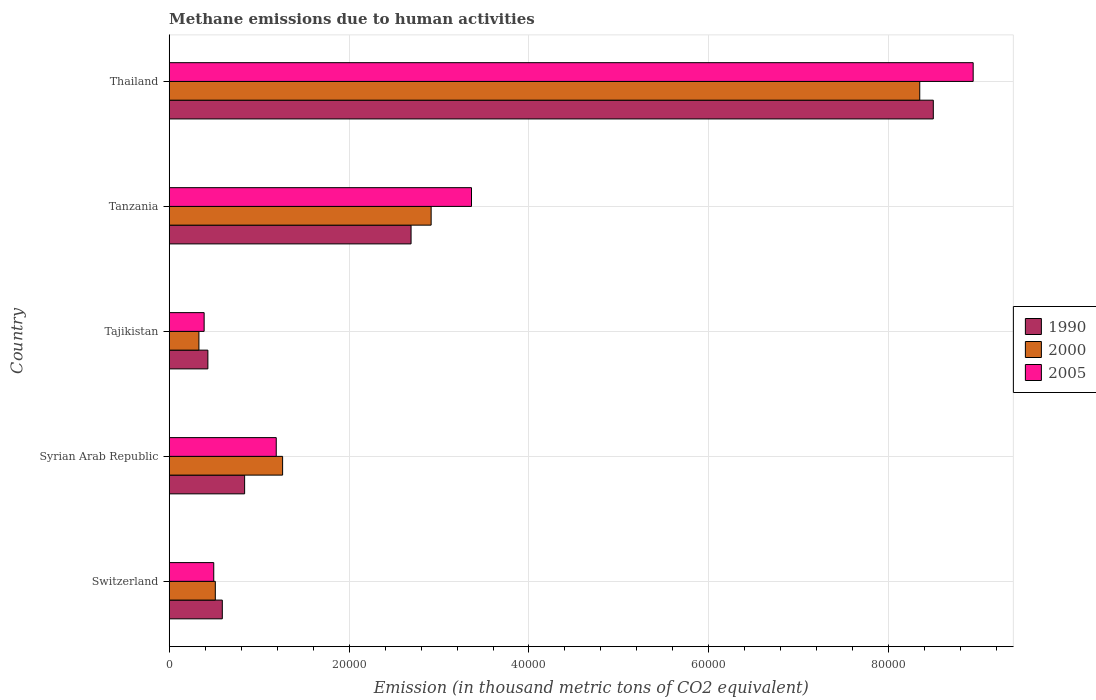How many groups of bars are there?
Your response must be concise. 5. Are the number of bars per tick equal to the number of legend labels?
Your answer should be very brief. Yes. How many bars are there on the 1st tick from the bottom?
Your answer should be compact. 3. What is the label of the 1st group of bars from the top?
Give a very brief answer. Thailand. In how many cases, is the number of bars for a given country not equal to the number of legend labels?
Give a very brief answer. 0. What is the amount of methane emitted in 1990 in Thailand?
Keep it short and to the point. 8.50e+04. Across all countries, what is the maximum amount of methane emitted in 1990?
Your response must be concise. 8.50e+04. Across all countries, what is the minimum amount of methane emitted in 2005?
Ensure brevity in your answer.  3884.9. In which country was the amount of methane emitted in 1990 maximum?
Give a very brief answer. Thailand. In which country was the amount of methane emitted in 2000 minimum?
Make the answer very short. Tajikistan. What is the total amount of methane emitted in 2000 in the graph?
Ensure brevity in your answer.  1.34e+05. What is the difference between the amount of methane emitted in 1990 in Syrian Arab Republic and that in Tajikistan?
Your answer should be compact. 4085.9. What is the difference between the amount of methane emitted in 2000 in Syrian Arab Republic and the amount of methane emitted in 1990 in Switzerland?
Your answer should be compact. 6704. What is the average amount of methane emitted in 2005 per country?
Make the answer very short. 2.87e+04. What is the difference between the amount of methane emitted in 2000 and amount of methane emitted in 2005 in Syrian Arab Republic?
Offer a terse response. 707.6. In how many countries, is the amount of methane emitted in 1990 greater than 24000 thousand metric tons?
Offer a very short reply. 2. What is the ratio of the amount of methane emitted in 2000 in Tajikistan to that in Tanzania?
Your answer should be very brief. 0.11. Is the amount of methane emitted in 2000 in Syrian Arab Republic less than that in Tanzania?
Provide a succinct answer. Yes. Is the difference between the amount of methane emitted in 2000 in Syrian Arab Republic and Tajikistan greater than the difference between the amount of methane emitted in 2005 in Syrian Arab Republic and Tajikistan?
Offer a very short reply. Yes. What is the difference between the highest and the second highest amount of methane emitted in 2000?
Ensure brevity in your answer.  5.43e+04. What is the difference between the highest and the lowest amount of methane emitted in 1990?
Make the answer very short. 8.07e+04. What does the 3rd bar from the top in Switzerland represents?
Your answer should be very brief. 1990. How many bars are there?
Offer a very short reply. 15. Are all the bars in the graph horizontal?
Ensure brevity in your answer.  Yes. How many countries are there in the graph?
Make the answer very short. 5. What is the difference between two consecutive major ticks on the X-axis?
Your response must be concise. 2.00e+04. Are the values on the major ticks of X-axis written in scientific E-notation?
Provide a succinct answer. No. Does the graph contain grids?
Offer a terse response. Yes. Where does the legend appear in the graph?
Offer a very short reply. Center right. How are the legend labels stacked?
Your answer should be very brief. Vertical. What is the title of the graph?
Keep it short and to the point. Methane emissions due to human activities. What is the label or title of the X-axis?
Provide a short and direct response. Emission (in thousand metric tons of CO2 equivalent). What is the label or title of the Y-axis?
Give a very brief answer. Country. What is the Emission (in thousand metric tons of CO2 equivalent) in 1990 in Switzerland?
Make the answer very short. 5904.8. What is the Emission (in thousand metric tons of CO2 equivalent) of 2000 in Switzerland?
Offer a very short reply. 5126.2. What is the Emission (in thousand metric tons of CO2 equivalent) of 2005 in Switzerland?
Your answer should be very brief. 4953.4. What is the Emission (in thousand metric tons of CO2 equivalent) of 1990 in Syrian Arab Republic?
Offer a terse response. 8384.9. What is the Emission (in thousand metric tons of CO2 equivalent) of 2000 in Syrian Arab Republic?
Keep it short and to the point. 1.26e+04. What is the Emission (in thousand metric tons of CO2 equivalent) of 2005 in Syrian Arab Republic?
Your answer should be compact. 1.19e+04. What is the Emission (in thousand metric tons of CO2 equivalent) of 1990 in Tajikistan?
Keep it short and to the point. 4299. What is the Emission (in thousand metric tons of CO2 equivalent) of 2000 in Tajikistan?
Offer a terse response. 3303.6. What is the Emission (in thousand metric tons of CO2 equivalent) in 2005 in Tajikistan?
Offer a very short reply. 3884.9. What is the Emission (in thousand metric tons of CO2 equivalent) in 1990 in Tanzania?
Make the answer very short. 2.69e+04. What is the Emission (in thousand metric tons of CO2 equivalent) of 2000 in Tanzania?
Ensure brevity in your answer.  2.91e+04. What is the Emission (in thousand metric tons of CO2 equivalent) of 2005 in Tanzania?
Offer a very short reply. 3.36e+04. What is the Emission (in thousand metric tons of CO2 equivalent) in 1990 in Thailand?
Your response must be concise. 8.50e+04. What is the Emission (in thousand metric tons of CO2 equivalent) of 2000 in Thailand?
Offer a very short reply. 8.34e+04. What is the Emission (in thousand metric tons of CO2 equivalent) of 2005 in Thailand?
Ensure brevity in your answer.  8.94e+04. Across all countries, what is the maximum Emission (in thousand metric tons of CO2 equivalent) in 1990?
Ensure brevity in your answer.  8.50e+04. Across all countries, what is the maximum Emission (in thousand metric tons of CO2 equivalent) of 2000?
Offer a terse response. 8.34e+04. Across all countries, what is the maximum Emission (in thousand metric tons of CO2 equivalent) of 2005?
Keep it short and to the point. 8.94e+04. Across all countries, what is the minimum Emission (in thousand metric tons of CO2 equivalent) in 1990?
Your answer should be compact. 4299. Across all countries, what is the minimum Emission (in thousand metric tons of CO2 equivalent) in 2000?
Ensure brevity in your answer.  3303.6. Across all countries, what is the minimum Emission (in thousand metric tons of CO2 equivalent) of 2005?
Your response must be concise. 3884.9. What is the total Emission (in thousand metric tons of CO2 equivalent) in 1990 in the graph?
Provide a short and direct response. 1.30e+05. What is the total Emission (in thousand metric tons of CO2 equivalent) of 2000 in the graph?
Provide a succinct answer. 1.34e+05. What is the total Emission (in thousand metric tons of CO2 equivalent) in 2005 in the graph?
Ensure brevity in your answer.  1.44e+05. What is the difference between the Emission (in thousand metric tons of CO2 equivalent) in 1990 in Switzerland and that in Syrian Arab Republic?
Ensure brevity in your answer.  -2480.1. What is the difference between the Emission (in thousand metric tons of CO2 equivalent) in 2000 in Switzerland and that in Syrian Arab Republic?
Provide a short and direct response. -7482.6. What is the difference between the Emission (in thousand metric tons of CO2 equivalent) of 2005 in Switzerland and that in Syrian Arab Republic?
Offer a terse response. -6947.8. What is the difference between the Emission (in thousand metric tons of CO2 equivalent) in 1990 in Switzerland and that in Tajikistan?
Make the answer very short. 1605.8. What is the difference between the Emission (in thousand metric tons of CO2 equivalent) in 2000 in Switzerland and that in Tajikistan?
Offer a very short reply. 1822.6. What is the difference between the Emission (in thousand metric tons of CO2 equivalent) of 2005 in Switzerland and that in Tajikistan?
Offer a very short reply. 1068.5. What is the difference between the Emission (in thousand metric tons of CO2 equivalent) in 1990 in Switzerland and that in Tanzania?
Offer a terse response. -2.10e+04. What is the difference between the Emission (in thousand metric tons of CO2 equivalent) of 2000 in Switzerland and that in Tanzania?
Your answer should be very brief. -2.40e+04. What is the difference between the Emission (in thousand metric tons of CO2 equivalent) in 2005 in Switzerland and that in Tanzania?
Ensure brevity in your answer.  -2.87e+04. What is the difference between the Emission (in thousand metric tons of CO2 equivalent) in 1990 in Switzerland and that in Thailand?
Make the answer very short. -7.91e+04. What is the difference between the Emission (in thousand metric tons of CO2 equivalent) in 2000 in Switzerland and that in Thailand?
Your answer should be compact. -7.83e+04. What is the difference between the Emission (in thousand metric tons of CO2 equivalent) of 2005 in Switzerland and that in Thailand?
Your response must be concise. -8.44e+04. What is the difference between the Emission (in thousand metric tons of CO2 equivalent) in 1990 in Syrian Arab Republic and that in Tajikistan?
Give a very brief answer. 4085.9. What is the difference between the Emission (in thousand metric tons of CO2 equivalent) of 2000 in Syrian Arab Republic and that in Tajikistan?
Make the answer very short. 9305.2. What is the difference between the Emission (in thousand metric tons of CO2 equivalent) in 2005 in Syrian Arab Republic and that in Tajikistan?
Offer a very short reply. 8016.3. What is the difference between the Emission (in thousand metric tons of CO2 equivalent) in 1990 in Syrian Arab Republic and that in Tanzania?
Give a very brief answer. -1.85e+04. What is the difference between the Emission (in thousand metric tons of CO2 equivalent) of 2000 in Syrian Arab Republic and that in Tanzania?
Ensure brevity in your answer.  -1.65e+04. What is the difference between the Emission (in thousand metric tons of CO2 equivalent) of 2005 in Syrian Arab Republic and that in Tanzania?
Your answer should be compact. -2.17e+04. What is the difference between the Emission (in thousand metric tons of CO2 equivalent) in 1990 in Syrian Arab Republic and that in Thailand?
Your answer should be compact. -7.66e+04. What is the difference between the Emission (in thousand metric tons of CO2 equivalent) of 2000 in Syrian Arab Republic and that in Thailand?
Your response must be concise. -7.08e+04. What is the difference between the Emission (in thousand metric tons of CO2 equivalent) in 2005 in Syrian Arab Republic and that in Thailand?
Keep it short and to the point. -7.75e+04. What is the difference between the Emission (in thousand metric tons of CO2 equivalent) in 1990 in Tajikistan and that in Tanzania?
Give a very brief answer. -2.26e+04. What is the difference between the Emission (in thousand metric tons of CO2 equivalent) of 2000 in Tajikistan and that in Tanzania?
Give a very brief answer. -2.58e+04. What is the difference between the Emission (in thousand metric tons of CO2 equivalent) in 2005 in Tajikistan and that in Tanzania?
Make the answer very short. -2.97e+04. What is the difference between the Emission (in thousand metric tons of CO2 equivalent) of 1990 in Tajikistan and that in Thailand?
Offer a very short reply. -8.07e+04. What is the difference between the Emission (in thousand metric tons of CO2 equivalent) of 2000 in Tajikistan and that in Thailand?
Your answer should be compact. -8.01e+04. What is the difference between the Emission (in thousand metric tons of CO2 equivalent) in 2005 in Tajikistan and that in Thailand?
Give a very brief answer. -8.55e+04. What is the difference between the Emission (in thousand metric tons of CO2 equivalent) of 1990 in Tanzania and that in Thailand?
Provide a succinct answer. -5.81e+04. What is the difference between the Emission (in thousand metric tons of CO2 equivalent) of 2000 in Tanzania and that in Thailand?
Make the answer very short. -5.43e+04. What is the difference between the Emission (in thousand metric tons of CO2 equivalent) in 2005 in Tanzania and that in Thailand?
Provide a succinct answer. -5.58e+04. What is the difference between the Emission (in thousand metric tons of CO2 equivalent) of 1990 in Switzerland and the Emission (in thousand metric tons of CO2 equivalent) of 2000 in Syrian Arab Republic?
Offer a terse response. -6704. What is the difference between the Emission (in thousand metric tons of CO2 equivalent) of 1990 in Switzerland and the Emission (in thousand metric tons of CO2 equivalent) of 2005 in Syrian Arab Republic?
Your answer should be compact. -5996.4. What is the difference between the Emission (in thousand metric tons of CO2 equivalent) of 2000 in Switzerland and the Emission (in thousand metric tons of CO2 equivalent) of 2005 in Syrian Arab Republic?
Give a very brief answer. -6775. What is the difference between the Emission (in thousand metric tons of CO2 equivalent) of 1990 in Switzerland and the Emission (in thousand metric tons of CO2 equivalent) of 2000 in Tajikistan?
Give a very brief answer. 2601.2. What is the difference between the Emission (in thousand metric tons of CO2 equivalent) of 1990 in Switzerland and the Emission (in thousand metric tons of CO2 equivalent) of 2005 in Tajikistan?
Ensure brevity in your answer.  2019.9. What is the difference between the Emission (in thousand metric tons of CO2 equivalent) of 2000 in Switzerland and the Emission (in thousand metric tons of CO2 equivalent) of 2005 in Tajikistan?
Provide a succinct answer. 1241.3. What is the difference between the Emission (in thousand metric tons of CO2 equivalent) of 1990 in Switzerland and the Emission (in thousand metric tons of CO2 equivalent) of 2000 in Tanzania?
Your response must be concise. -2.32e+04. What is the difference between the Emission (in thousand metric tons of CO2 equivalent) in 1990 in Switzerland and the Emission (in thousand metric tons of CO2 equivalent) in 2005 in Tanzania?
Give a very brief answer. -2.77e+04. What is the difference between the Emission (in thousand metric tons of CO2 equivalent) in 2000 in Switzerland and the Emission (in thousand metric tons of CO2 equivalent) in 2005 in Tanzania?
Provide a succinct answer. -2.85e+04. What is the difference between the Emission (in thousand metric tons of CO2 equivalent) in 1990 in Switzerland and the Emission (in thousand metric tons of CO2 equivalent) in 2000 in Thailand?
Keep it short and to the point. -7.75e+04. What is the difference between the Emission (in thousand metric tons of CO2 equivalent) in 1990 in Switzerland and the Emission (in thousand metric tons of CO2 equivalent) in 2005 in Thailand?
Ensure brevity in your answer.  -8.35e+04. What is the difference between the Emission (in thousand metric tons of CO2 equivalent) in 2000 in Switzerland and the Emission (in thousand metric tons of CO2 equivalent) in 2005 in Thailand?
Keep it short and to the point. -8.43e+04. What is the difference between the Emission (in thousand metric tons of CO2 equivalent) of 1990 in Syrian Arab Republic and the Emission (in thousand metric tons of CO2 equivalent) of 2000 in Tajikistan?
Your answer should be compact. 5081.3. What is the difference between the Emission (in thousand metric tons of CO2 equivalent) in 1990 in Syrian Arab Republic and the Emission (in thousand metric tons of CO2 equivalent) in 2005 in Tajikistan?
Make the answer very short. 4500. What is the difference between the Emission (in thousand metric tons of CO2 equivalent) of 2000 in Syrian Arab Republic and the Emission (in thousand metric tons of CO2 equivalent) of 2005 in Tajikistan?
Give a very brief answer. 8723.9. What is the difference between the Emission (in thousand metric tons of CO2 equivalent) in 1990 in Syrian Arab Republic and the Emission (in thousand metric tons of CO2 equivalent) in 2000 in Tanzania?
Ensure brevity in your answer.  -2.07e+04. What is the difference between the Emission (in thousand metric tons of CO2 equivalent) of 1990 in Syrian Arab Republic and the Emission (in thousand metric tons of CO2 equivalent) of 2005 in Tanzania?
Your response must be concise. -2.52e+04. What is the difference between the Emission (in thousand metric tons of CO2 equivalent) of 2000 in Syrian Arab Republic and the Emission (in thousand metric tons of CO2 equivalent) of 2005 in Tanzania?
Give a very brief answer. -2.10e+04. What is the difference between the Emission (in thousand metric tons of CO2 equivalent) in 1990 in Syrian Arab Republic and the Emission (in thousand metric tons of CO2 equivalent) in 2000 in Thailand?
Provide a short and direct response. -7.51e+04. What is the difference between the Emission (in thousand metric tons of CO2 equivalent) of 1990 in Syrian Arab Republic and the Emission (in thousand metric tons of CO2 equivalent) of 2005 in Thailand?
Ensure brevity in your answer.  -8.10e+04. What is the difference between the Emission (in thousand metric tons of CO2 equivalent) in 2000 in Syrian Arab Republic and the Emission (in thousand metric tons of CO2 equivalent) in 2005 in Thailand?
Your answer should be compact. -7.68e+04. What is the difference between the Emission (in thousand metric tons of CO2 equivalent) of 1990 in Tajikistan and the Emission (in thousand metric tons of CO2 equivalent) of 2000 in Tanzania?
Make the answer very short. -2.48e+04. What is the difference between the Emission (in thousand metric tons of CO2 equivalent) of 1990 in Tajikistan and the Emission (in thousand metric tons of CO2 equivalent) of 2005 in Tanzania?
Keep it short and to the point. -2.93e+04. What is the difference between the Emission (in thousand metric tons of CO2 equivalent) in 2000 in Tajikistan and the Emission (in thousand metric tons of CO2 equivalent) in 2005 in Tanzania?
Give a very brief answer. -3.03e+04. What is the difference between the Emission (in thousand metric tons of CO2 equivalent) in 1990 in Tajikistan and the Emission (in thousand metric tons of CO2 equivalent) in 2000 in Thailand?
Keep it short and to the point. -7.91e+04. What is the difference between the Emission (in thousand metric tons of CO2 equivalent) in 1990 in Tajikistan and the Emission (in thousand metric tons of CO2 equivalent) in 2005 in Thailand?
Provide a short and direct response. -8.51e+04. What is the difference between the Emission (in thousand metric tons of CO2 equivalent) of 2000 in Tajikistan and the Emission (in thousand metric tons of CO2 equivalent) of 2005 in Thailand?
Your answer should be very brief. -8.61e+04. What is the difference between the Emission (in thousand metric tons of CO2 equivalent) in 1990 in Tanzania and the Emission (in thousand metric tons of CO2 equivalent) in 2000 in Thailand?
Ensure brevity in your answer.  -5.66e+04. What is the difference between the Emission (in thousand metric tons of CO2 equivalent) of 1990 in Tanzania and the Emission (in thousand metric tons of CO2 equivalent) of 2005 in Thailand?
Give a very brief answer. -6.25e+04. What is the difference between the Emission (in thousand metric tons of CO2 equivalent) in 2000 in Tanzania and the Emission (in thousand metric tons of CO2 equivalent) in 2005 in Thailand?
Your response must be concise. -6.03e+04. What is the average Emission (in thousand metric tons of CO2 equivalent) of 1990 per country?
Provide a short and direct response. 2.61e+04. What is the average Emission (in thousand metric tons of CO2 equivalent) in 2000 per country?
Offer a very short reply. 2.67e+04. What is the average Emission (in thousand metric tons of CO2 equivalent) of 2005 per country?
Offer a very short reply. 2.87e+04. What is the difference between the Emission (in thousand metric tons of CO2 equivalent) of 1990 and Emission (in thousand metric tons of CO2 equivalent) of 2000 in Switzerland?
Provide a short and direct response. 778.6. What is the difference between the Emission (in thousand metric tons of CO2 equivalent) in 1990 and Emission (in thousand metric tons of CO2 equivalent) in 2005 in Switzerland?
Offer a very short reply. 951.4. What is the difference between the Emission (in thousand metric tons of CO2 equivalent) of 2000 and Emission (in thousand metric tons of CO2 equivalent) of 2005 in Switzerland?
Give a very brief answer. 172.8. What is the difference between the Emission (in thousand metric tons of CO2 equivalent) in 1990 and Emission (in thousand metric tons of CO2 equivalent) in 2000 in Syrian Arab Republic?
Keep it short and to the point. -4223.9. What is the difference between the Emission (in thousand metric tons of CO2 equivalent) in 1990 and Emission (in thousand metric tons of CO2 equivalent) in 2005 in Syrian Arab Republic?
Offer a terse response. -3516.3. What is the difference between the Emission (in thousand metric tons of CO2 equivalent) in 2000 and Emission (in thousand metric tons of CO2 equivalent) in 2005 in Syrian Arab Republic?
Make the answer very short. 707.6. What is the difference between the Emission (in thousand metric tons of CO2 equivalent) of 1990 and Emission (in thousand metric tons of CO2 equivalent) of 2000 in Tajikistan?
Your response must be concise. 995.4. What is the difference between the Emission (in thousand metric tons of CO2 equivalent) of 1990 and Emission (in thousand metric tons of CO2 equivalent) of 2005 in Tajikistan?
Your response must be concise. 414.1. What is the difference between the Emission (in thousand metric tons of CO2 equivalent) in 2000 and Emission (in thousand metric tons of CO2 equivalent) in 2005 in Tajikistan?
Ensure brevity in your answer.  -581.3. What is the difference between the Emission (in thousand metric tons of CO2 equivalent) in 1990 and Emission (in thousand metric tons of CO2 equivalent) in 2000 in Tanzania?
Offer a very short reply. -2232.7. What is the difference between the Emission (in thousand metric tons of CO2 equivalent) in 1990 and Emission (in thousand metric tons of CO2 equivalent) in 2005 in Tanzania?
Offer a terse response. -6719. What is the difference between the Emission (in thousand metric tons of CO2 equivalent) of 2000 and Emission (in thousand metric tons of CO2 equivalent) of 2005 in Tanzania?
Make the answer very short. -4486.3. What is the difference between the Emission (in thousand metric tons of CO2 equivalent) in 1990 and Emission (in thousand metric tons of CO2 equivalent) in 2000 in Thailand?
Offer a very short reply. 1507.2. What is the difference between the Emission (in thousand metric tons of CO2 equivalent) of 1990 and Emission (in thousand metric tons of CO2 equivalent) of 2005 in Thailand?
Make the answer very short. -4432.2. What is the difference between the Emission (in thousand metric tons of CO2 equivalent) of 2000 and Emission (in thousand metric tons of CO2 equivalent) of 2005 in Thailand?
Keep it short and to the point. -5939.4. What is the ratio of the Emission (in thousand metric tons of CO2 equivalent) in 1990 in Switzerland to that in Syrian Arab Republic?
Your answer should be very brief. 0.7. What is the ratio of the Emission (in thousand metric tons of CO2 equivalent) in 2000 in Switzerland to that in Syrian Arab Republic?
Keep it short and to the point. 0.41. What is the ratio of the Emission (in thousand metric tons of CO2 equivalent) of 2005 in Switzerland to that in Syrian Arab Republic?
Ensure brevity in your answer.  0.42. What is the ratio of the Emission (in thousand metric tons of CO2 equivalent) of 1990 in Switzerland to that in Tajikistan?
Keep it short and to the point. 1.37. What is the ratio of the Emission (in thousand metric tons of CO2 equivalent) of 2000 in Switzerland to that in Tajikistan?
Your answer should be very brief. 1.55. What is the ratio of the Emission (in thousand metric tons of CO2 equivalent) in 2005 in Switzerland to that in Tajikistan?
Your answer should be compact. 1.27. What is the ratio of the Emission (in thousand metric tons of CO2 equivalent) of 1990 in Switzerland to that in Tanzania?
Ensure brevity in your answer.  0.22. What is the ratio of the Emission (in thousand metric tons of CO2 equivalent) in 2000 in Switzerland to that in Tanzania?
Offer a very short reply. 0.18. What is the ratio of the Emission (in thousand metric tons of CO2 equivalent) in 2005 in Switzerland to that in Tanzania?
Ensure brevity in your answer.  0.15. What is the ratio of the Emission (in thousand metric tons of CO2 equivalent) in 1990 in Switzerland to that in Thailand?
Offer a very short reply. 0.07. What is the ratio of the Emission (in thousand metric tons of CO2 equivalent) in 2000 in Switzerland to that in Thailand?
Your answer should be compact. 0.06. What is the ratio of the Emission (in thousand metric tons of CO2 equivalent) of 2005 in Switzerland to that in Thailand?
Provide a short and direct response. 0.06. What is the ratio of the Emission (in thousand metric tons of CO2 equivalent) of 1990 in Syrian Arab Republic to that in Tajikistan?
Give a very brief answer. 1.95. What is the ratio of the Emission (in thousand metric tons of CO2 equivalent) in 2000 in Syrian Arab Republic to that in Tajikistan?
Keep it short and to the point. 3.82. What is the ratio of the Emission (in thousand metric tons of CO2 equivalent) of 2005 in Syrian Arab Republic to that in Tajikistan?
Your response must be concise. 3.06. What is the ratio of the Emission (in thousand metric tons of CO2 equivalent) in 1990 in Syrian Arab Republic to that in Tanzania?
Your answer should be very brief. 0.31. What is the ratio of the Emission (in thousand metric tons of CO2 equivalent) of 2000 in Syrian Arab Republic to that in Tanzania?
Offer a very short reply. 0.43. What is the ratio of the Emission (in thousand metric tons of CO2 equivalent) in 2005 in Syrian Arab Republic to that in Tanzania?
Provide a succinct answer. 0.35. What is the ratio of the Emission (in thousand metric tons of CO2 equivalent) of 1990 in Syrian Arab Republic to that in Thailand?
Your response must be concise. 0.1. What is the ratio of the Emission (in thousand metric tons of CO2 equivalent) of 2000 in Syrian Arab Republic to that in Thailand?
Make the answer very short. 0.15. What is the ratio of the Emission (in thousand metric tons of CO2 equivalent) in 2005 in Syrian Arab Republic to that in Thailand?
Make the answer very short. 0.13. What is the ratio of the Emission (in thousand metric tons of CO2 equivalent) of 1990 in Tajikistan to that in Tanzania?
Provide a succinct answer. 0.16. What is the ratio of the Emission (in thousand metric tons of CO2 equivalent) in 2000 in Tajikistan to that in Tanzania?
Offer a terse response. 0.11. What is the ratio of the Emission (in thousand metric tons of CO2 equivalent) of 2005 in Tajikistan to that in Tanzania?
Keep it short and to the point. 0.12. What is the ratio of the Emission (in thousand metric tons of CO2 equivalent) of 1990 in Tajikistan to that in Thailand?
Your answer should be very brief. 0.05. What is the ratio of the Emission (in thousand metric tons of CO2 equivalent) of 2000 in Tajikistan to that in Thailand?
Offer a terse response. 0.04. What is the ratio of the Emission (in thousand metric tons of CO2 equivalent) of 2005 in Tajikistan to that in Thailand?
Provide a short and direct response. 0.04. What is the ratio of the Emission (in thousand metric tons of CO2 equivalent) of 1990 in Tanzania to that in Thailand?
Provide a short and direct response. 0.32. What is the ratio of the Emission (in thousand metric tons of CO2 equivalent) of 2000 in Tanzania to that in Thailand?
Your answer should be compact. 0.35. What is the ratio of the Emission (in thousand metric tons of CO2 equivalent) in 2005 in Tanzania to that in Thailand?
Your response must be concise. 0.38. What is the difference between the highest and the second highest Emission (in thousand metric tons of CO2 equivalent) in 1990?
Offer a terse response. 5.81e+04. What is the difference between the highest and the second highest Emission (in thousand metric tons of CO2 equivalent) of 2000?
Provide a succinct answer. 5.43e+04. What is the difference between the highest and the second highest Emission (in thousand metric tons of CO2 equivalent) in 2005?
Provide a succinct answer. 5.58e+04. What is the difference between the highest and the lowest Emission (in thousand metric tons of CO2 equivalent) of 1990?
Your answer should be very brief. 8.07e+04. What is the difference between the highest and the lowest Emission (in thousand metric tons of CO2 equivalent) of 2000?
Ensure brevity in your answer.  8.01e+04. What is the difference between the highest and the lowest Emission (in thousand metric tons of CO2 equivalent) of 2005?
Make the answer very short. 8.55e+04. 